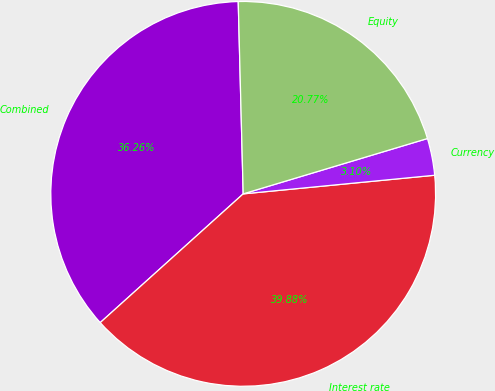Convert chart. <chart><loc_0><loc_0><loc_500><loc_500><pie_chart><fcel>Combined<fcel>Interest rate<fcel>Currency<fcel>Equity<nl><fcel>36.26%<fcel>39.88%<fcel>3.1%<fcel>20.77%<nl></chart> 